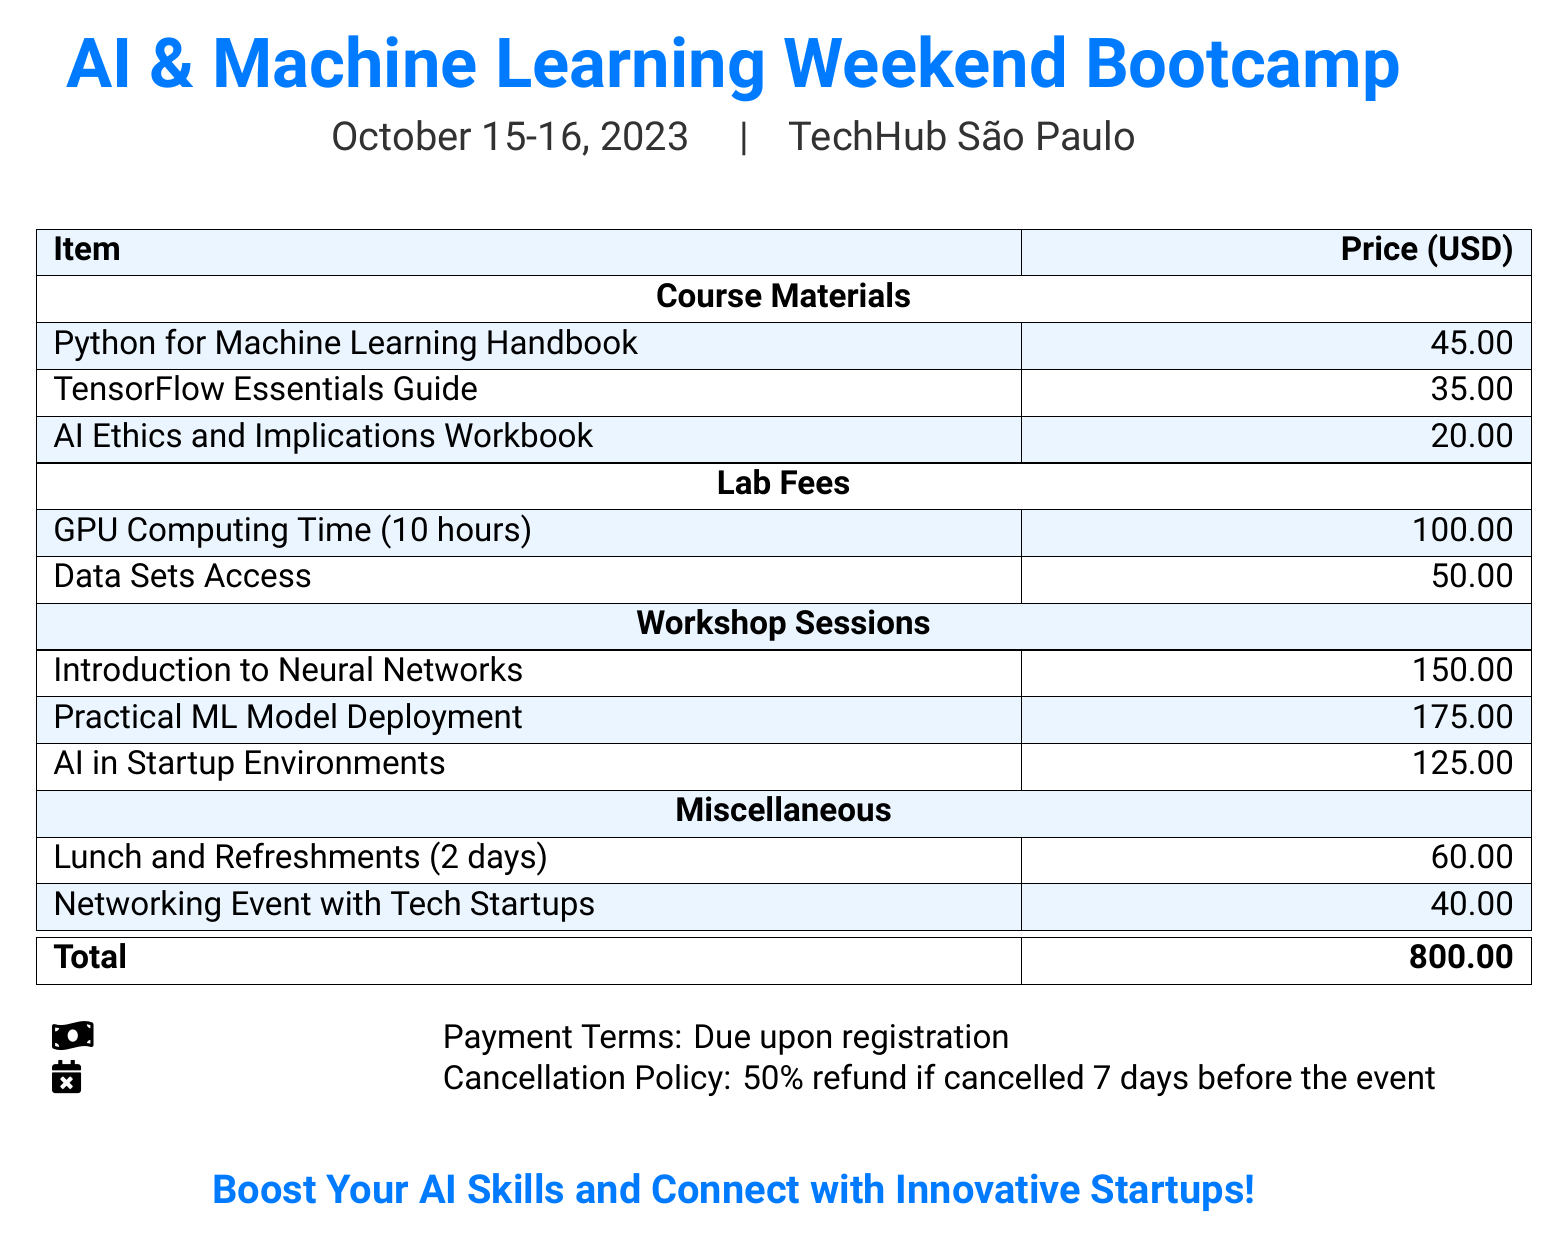What is the date of the bootcamp? The date is explicitly stated in the document, listed as October 15-16, 2023.
Answer: October 15-16, 2023 What is the total cost for the bootcamp? The total cost is listed at the bottom of the bill after summing all individual items.
Answer: 800.00 How much is the GPU Computing Time? The fee for GPU Computing Time is specifically mentioned in the lab fees section.
Answer: 100.00 What materials are included in the course? The document lists the course materials under the specific section for Course Materials, namely three different titles.
Answer: Python for Machine Learning Handbook, TensorFlow Essentials Guide, AI Ethics and Implications Workbook What is the cancellation policy percentage for refunds? The cancellation policy is noted in the document, stating a specific percentage of refund for cancellations.
Answer: 50% How much does the networking event cost? The cost for the networking event is listed in the Miscellaneous section.
Answer: 40.00 Which workshop session has the highest fee? The fees for workshop sessions are provided, and the one with the highest amount can be easily identified.
Answer: Practical ML Model Deployment How many hours of GPU computing time are provided? The document explicitly states the duration of GPU computing time included in the fees.
Answer: 10 hours What is the payment term for registration? The payment terms are mentioned directly under payment details in the document.
Answer: Due upon registration 